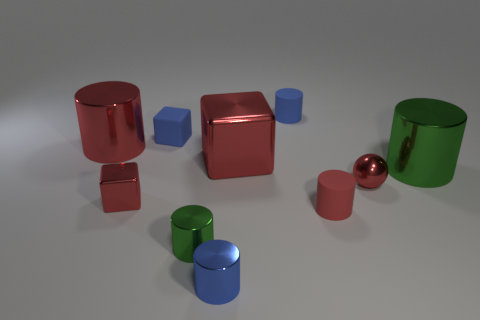How many things are large red rubber things or tiny blue objects in front of the large red cylinder?
Provide a short and direct response. 1. Is there anything else that has the same shape as the red rubber object?
Provide a short and direct response. Yes. There is a rubber thing that is in front of the blue matte block; is its size the same as the tiny metallic sphere?
Ensure brevity in your answer.  Yes. How many matte objects are gray blocks or blue cylinders?
Give a very brief answer. 1. There is a green cylinder on the left side of the metal ball; how big is it?
Your response must be concise. Small. Is the shape of the small green metallic object the same as the large green object?
Give a very brief answer. Yes. How many large things are cyan spheres or blue cubes?
Ensure brevity in your answer.  0. Are there any small blue rubber cylinders in front of the blue metal cylinder?
Give a very brief answer. No. Are there an equal number of small green cylinders that are in front of the tiny blue shiny cylinder and green shiny objects?
Ensure brevity in your answer.  No. What size is the blue metal object that is the same shape as the small red matte object?
Ensure brevity in your answer.  Small. 